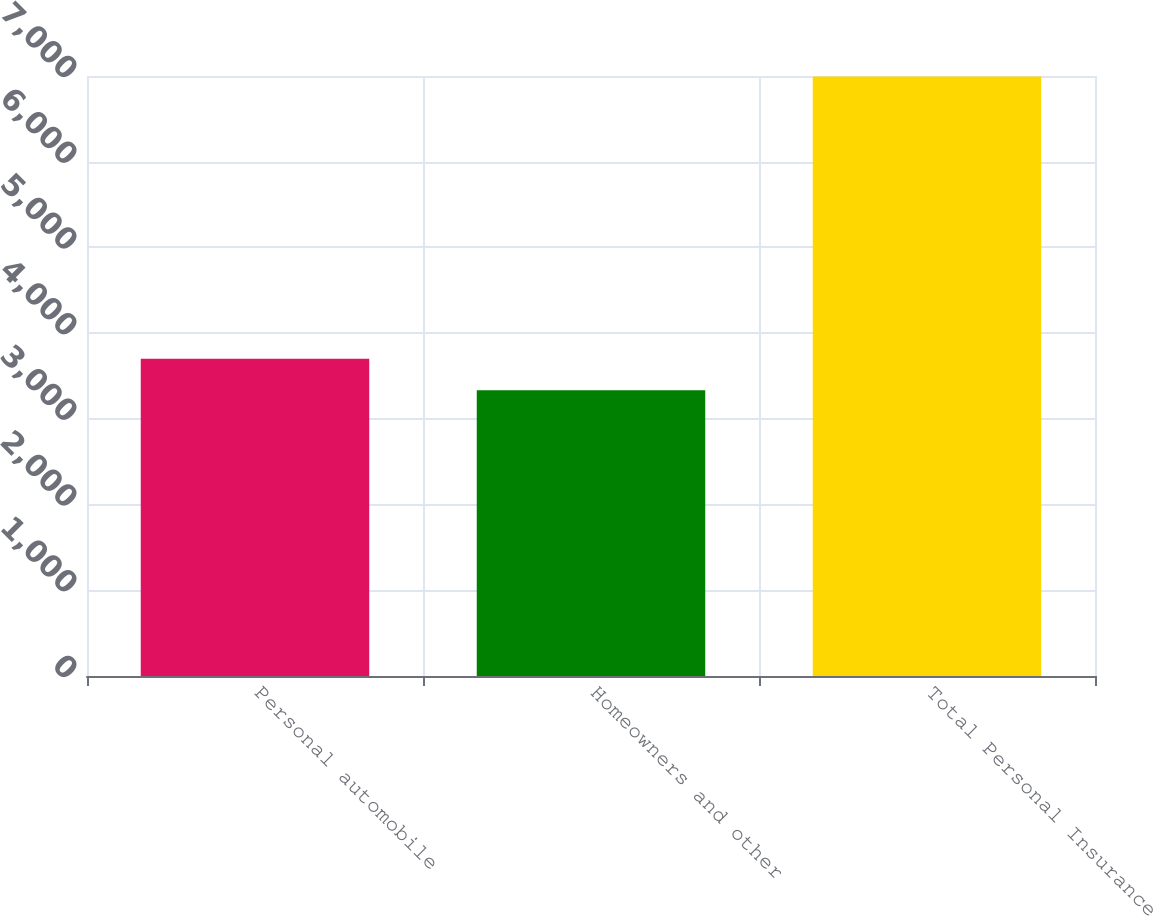Convert chart to OTSL. <chart><loc_0><loc_0><loc_500><loc_500><bar_chart><fcel>Personal automobile<fcel>Homeowners and other<fcel>Total Personal Insurance<nl><fcel>3701<fcel>3335<fcel>6995<nl></chart> 